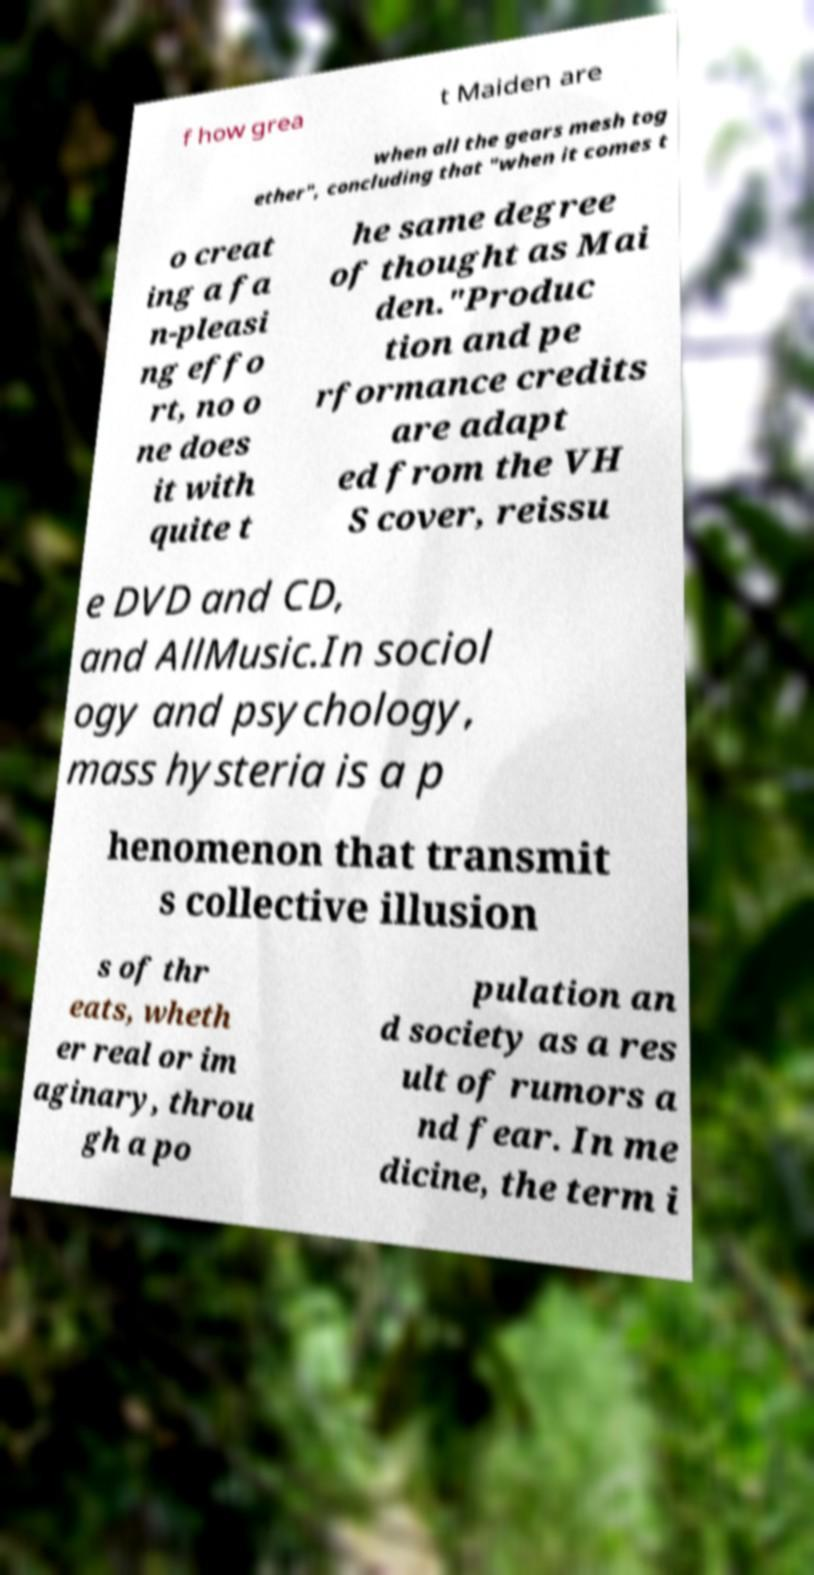Please identify and transcribe the text found in this image. f how grea t Maiden are when all the gears mesh tog ether", concluding that "when it comes t o creat ing a fa n-pleasi ng effo rt, no o ne does it with quite t he same degree of thought as Mai den."Produc tion and pe rformance credits are adapt ed from the VH S cover, reissu e DVD and CD, and AllMusic.In sociol ogy and psychology, mass hysteria is a p henomenon that transmit s collective illusion s of thr eats, wheth er real or im aginary, throu gh a po pulation an d society as a res ult of rumors a nd fear. In me dicine, the term i 